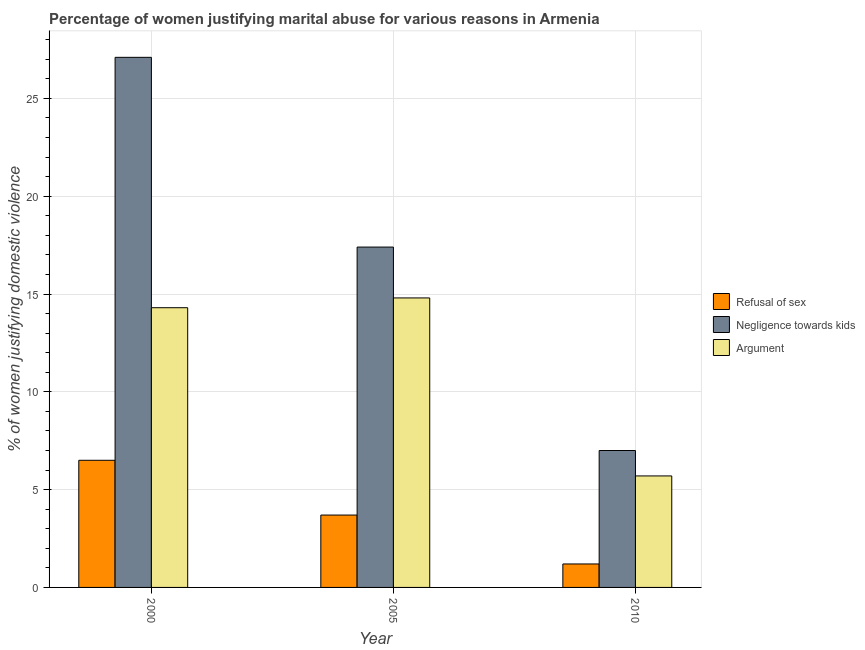How many different coloured bars are there?
Provide a short and direct response. 3. Are the number of bars on each tick of the X-axis equal?
Your response must be concise. Yes. How many bars are there on the 2nd tick from the left?
Give a very brief answer. 3. How many bars are there on the 1st tick from the right?
Give a very brief answer. 3. In how many cases, is the number of bars for a given year not equal to the number of legend labels?
Make the answer very short. 0. Across all years, what is the maximum percentage of women justifying domestic violence due to negligence towards kids?
Your answer should be very brief. 27.1. Across all years, what is the minimum percentage of women justifying domestic violence due to refusal of sex?
Provide a short and direct response. 1.2. In which year was the percentage of women justifying domestic violence due to refusal of sex maximum?
Provide a short and direct response. 2000. In which year was the percentage of women justifying domestic violence due to refusal of sex minimum?
Ensure brevity in your answer.  2010. What is the total percentage of women justifying domestic violence due to refusal of sex in the graph?
Keep it short and to the point. 11.4. What is the difference between the percentage of women justifying domestic violence due to arguments in 2010 and the percentage of women justifying domestic violence due to negligence towards kids in 2000?
Keep it short and to the point. -8.6. What is the average percentage of women justifying domestic violence due to arguments per year?
Offer a terse response. 11.6. In the year 2000, what is the difference between the percentage of women justifying domestic violence due to refusal of sex and percentage of women justifying domestic violence due to negligence towards kids?
Keep it short and to the point. 0. In how many years, is the percentage of women justifying domestic violence due to negligence towards kids greater than 22 %?
Provide a short and direct response. 1. What is the ratio of the percentage of women justifying domestic violence due to refusal of sex in 2000 to that in 2005?
Offer a terse response. 1.76. What is the difference between the highest and the second highest percentage of women justifying domestic violence due to arguments?
Ensure brevity in your answer.  0.5. What is the difference between the highest and the lowest percentage of women justifying domestic violence due to negligence towards kids?
Your response must be concise. 20.1. In how many years, is the percentage of women justifying domestic violence due to arguments greater than the average percentage of women justifying domestic violence due to arguments taken over all years?
Your response must be concise. 2. Is the sum of the percentage of women justifying domestic violence due to negligence towards kids in 2000 and 2010 greater than the maximum percentage of women justifying domestic violence due to refusal of sex across all years?
Give a very brief answer. Yes. What does the 3rd bar from the left in 2010 represents?
Your response must be concise. Argument. What does the 2nd bar from the right in 2005 represents?
Offer a terse response. Negligence towards kids. How many years are there in the graph?
Ensure brevity in your answer.  3. Where does the legend appear in the graph?
Provide a short and direct response. Center right. What is the title of the graph?
Provide a succinct answer. Percentage of women justifying marital abuse for various reasons in Armenia. What is the label or title of the Y-axis?
Give a very brief answer. % of women justifying domestic violence. What is the % of women justifying domestic violence of Refusal of sex in 2000?
Your answer should be very brief. 6.5. What is the % of women justifying domestic violence in Negligence towards kids in 2000?
Make the answer very short. 27.1. What is the % of women justifying domestic violence of Argument in 2000?
Keep it short and to the point. 14.3. What is the % of women justifying domestic violence in Negligence towards kids in 2005?
Your answer should be compact. 17.4. What is the % of women justifying domestic violence in Refusal of sex in 2010?
Provide a succinct answer. 1.2. Across all years, what is the maximum % of women justifying domestic violence in Negligence towards kids?
Your response must be concise. 27.1. Across all years, what is the minimum % of women justifying domestic violence of Argument?
Your answer should be compact. 5.7. What is the total % of women justifying domestic violence in Negligence towards kids in the graph?
Ensure brevity in your answer.  51.5. What is the total % of women justifying domestic violence of Argument in the graph?
Make the answer very short. 34.8. What is the difference between the % of women justifying domestic violence in Refusal of sex in 2000 and that in 2005?
Your answer should be very brief. 2.8. What is the difference between the % of women justifying domestic violence in Negligence towards kids in 2000 and that in 2010?
Offer a terse response. 20.1. What is the difference between the % of women justifying domestic violence in Negligence towards kids in 2005 and that in 2010?
Ensure brevity in your answer.  10.4. What is the difference between the % of women justifying domestic violence of Refusal of sex in 2000 and the % of women justifying domestic violence of Argument in 2005?
Provide a succinct answer. -8.3. What is the difference between the % of women justifying domestic violence in Negligence towards kids in 2000 and the % of women justifying domestic violence in Argument in 2005?
Keep it short and to the point. 12.3. What is the difference between the % of women justifying domestic violence in Negligence towards kids in 2000 and the % of women justifying domestic violence in Argument in 2010?
Ensure brevity in your answer.  21.4. What is the difference between the % of women justifying domestic violence of Refusal of sex in 2005 and the % of women justifying domestic violence of Argument in 2010?
Your answer should be compact. -2. What is the difference between the % of women justifying domestic violence in Negligence towards kids in 2005 and the % of women justifying domestic violence in Argument in 2010?
Offer a very short reply. 11.7. What is the average % of women justifying domestic violence of Refusal of sex per year?
Offer a terse response. 3.8. What is the average % of women justifying domestic violence of Negligence towards kids per year?
Offer a terse response. 17.17. What is the average % of women justifying domestic violence in Argument per year?
Offer a terse response. 11.6. In the year 2000, what is the difference between the % of women justifying domestic violence in Refusal of sex and % of women justifying domestic violence in Negligence towards kids?
Keep it short and to the point. -20.6. In the year 2000, what is the difference between the % of women justifying domestic violence of Refusal of sex and % of women justifying domestic violence of Argument?
Provide a succinct answer. -7.8. In the year 2005, what is the difference between the % of women justifying domestic violence of Refusal of sex and % of women justifying domestic violence of Negligence towards kids?
Keep it short and to the point. -13.7. In the year 2005, what is the difference between the % of women justifying domestic violence in Negligence towards kids and % of women justifying domestic violence in Argument?
Your answer should be compact. 2.6. In the year 2010, what is the difference between the % of women justifying domestic violence of Refusal of sex and % of women justifying domestic violence of Negligence towards kids?
Your response must be concise. -5.8. What is the ratio of the % of women justifying domestic violence of Refusal of sex in 2000 to that in 2005?
Provide a short and direct response. 1.76. What is the ratio of the % of women justifying domestic violence in Negligence towards kids in 2000 to that in 2005?
Your answer should be compact. 1.56. What is the ratio of the % of women justifying domestic violence in Argument in 2000 to that in 2005?
Provide a short and direct response. 0.97. What is the ratio of the % of women justifying domestic violence of Refusal of sex in 2000 to that in 2010?
Provide a short and direct response. 5.42. What is the ratio of the % of women justifying domestic violence of Negligence towards kids in 2000 to that in 2010?
Offer a terse response. 3.87. What is the ratio of the % of women justifying domestic violence of Argument in 2000 to that in 2010?
Make the answer very short. 2.51. What is the ratio of the % of women justifying domestic violence of Refusal of sex in 2005 to that in 2010?
Give a very brief answer. 3.08. What is the ratio of the % of women justifying domestic violence in Negligence towards kids in 2005 to that in 2010?
Offer a very short reply. 2.49. What is the ratio of the % of women justifying domestic violence of Argument in 2005 to that in 2010?
Give a very brief answer. 2.6. What is the difference between the highest and the second highest % of women justifying domestic violence in Negligence towards kids?
Offer a very short reply. 9.7. What is the difference between the highest and the lowest % of women justifying domestic violence of Refusal of sex?
Make the answer very short. 5.3. What is the difference between the highest and the lowest % of women justifying domestic violence in Negligence towards kids?
Provide a short and direct response. 20.1. What is the difference between the highest and the lowest % of women justifying domestic violence in Argument?
Offer a very short reply. 9.1. 